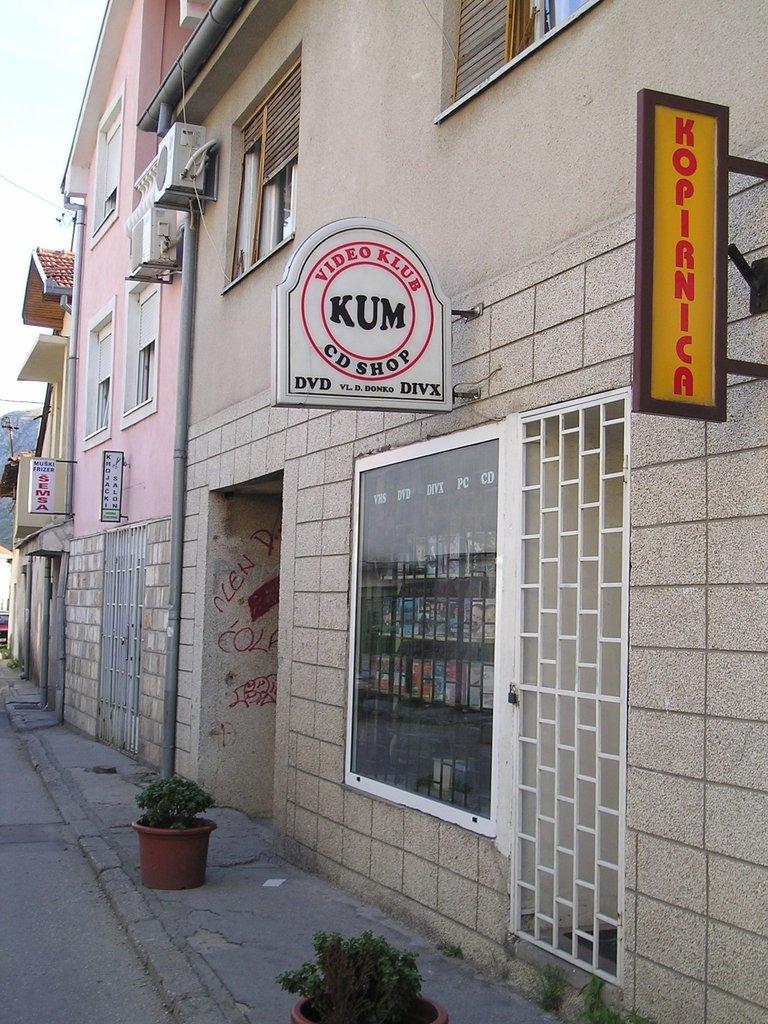In one or two sentences, can you explain what this image depicts? In this image we can see buildings and boards are attached to the buildings. Bottom of the image pots are there. 